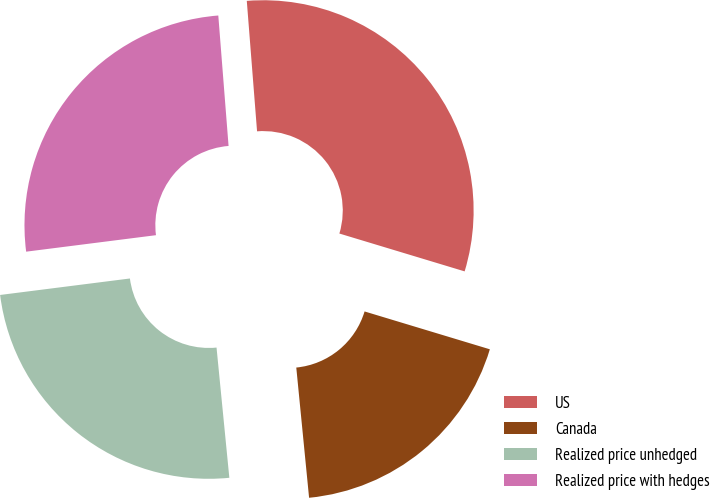<chart> <loc_0><loc_0><loc_500><loc_500><pie_chart><fcel>US<fcel>Canada<fcel>Realized price unhedged<fcel>Realized price with hedges<nl><fcel>30.92%<fcel>18.77%<fcel>24.55%<fcel>25.76%<nl></chart> 